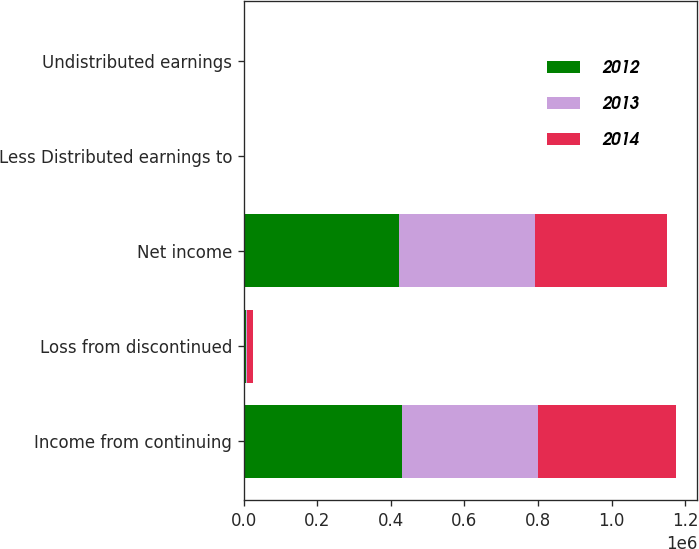Convert chart. <chart><loc_0><loc_0><loc_500><loc_500><stacked_bar_chart><ecel><fcel>Income from continuing<fcel>Loss from discontinued<fcel>Net income<fcel>Less Distributed earnings to<fcel>Undistributed earnings<nl><fcel>2012<fcel>429841<fcel>6733<fcel>423108<fcel>63<fcel>57<nl><fcel>2013<fcel>370844<fcel>1580<fcel>369264<fcel>60<fcel>84<nl><fcel>2014<fcel>373602<fcel>15532<fcel>358070<fcel>86<fcel>58<nl></chart> 